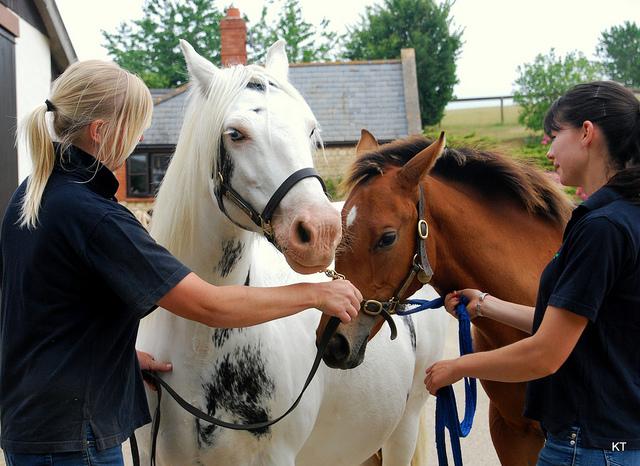How many ponytails are visible in the picture?
Write a very short answer. 1. Which horse has a blue rein?
Keep it brief. Brown horse. What are the horses wearing?
Concise answer only. Bridles. Are there people in the picture?
Keep it brief. Yes. 